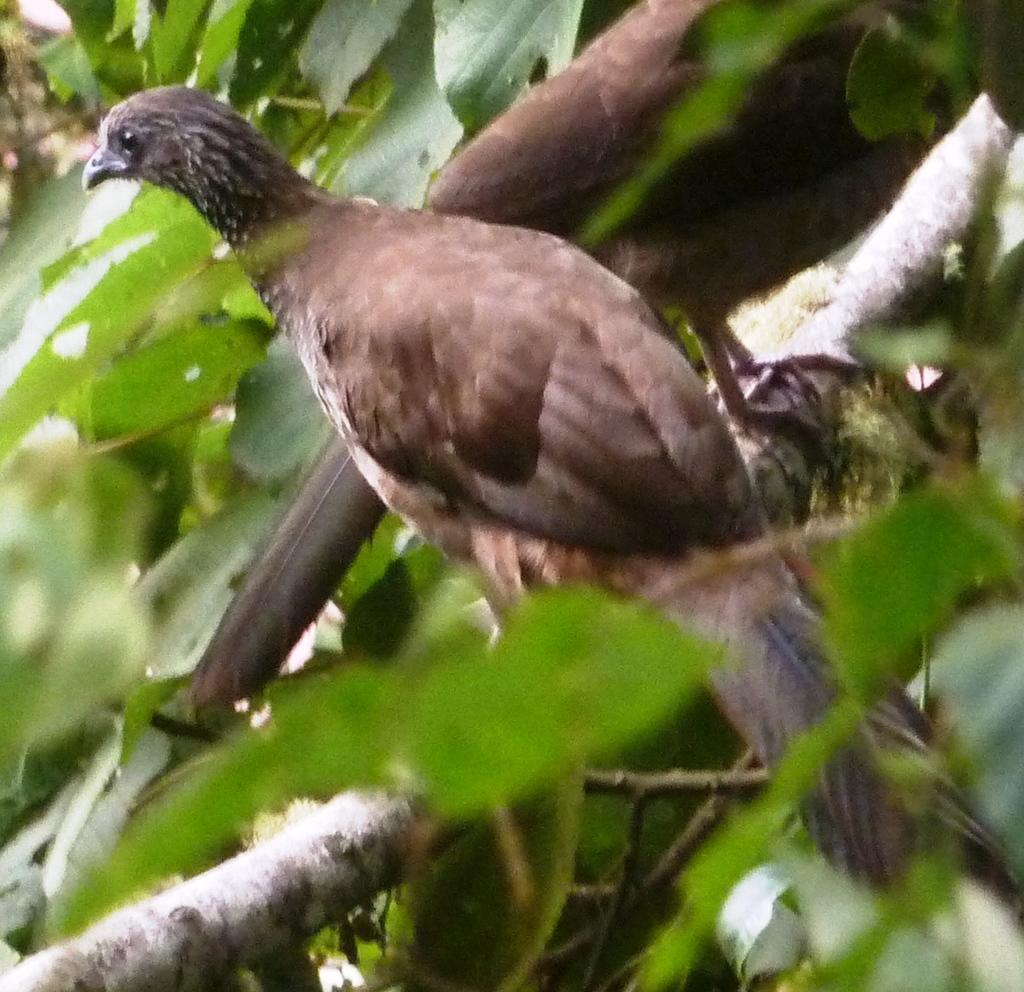Describe this image in one or two sentences. In this image, we can see two birds are on the tree stem. Here we can see tree leaves. 